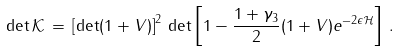<formula> <loc_0><loc_0><loc_500><loc_500>\det { \mathcal { K } } \, = \, \left [ \det ( 1 + V ) \right ] ^ { 2 } \, \det \left [ 1 - \frac { 1 + \gamma _ { 3 } } { 2 } ( 1 + V ) e ^ { - 2 \epsilon { \mathcal { H } } } \right ] \, .</formula> 